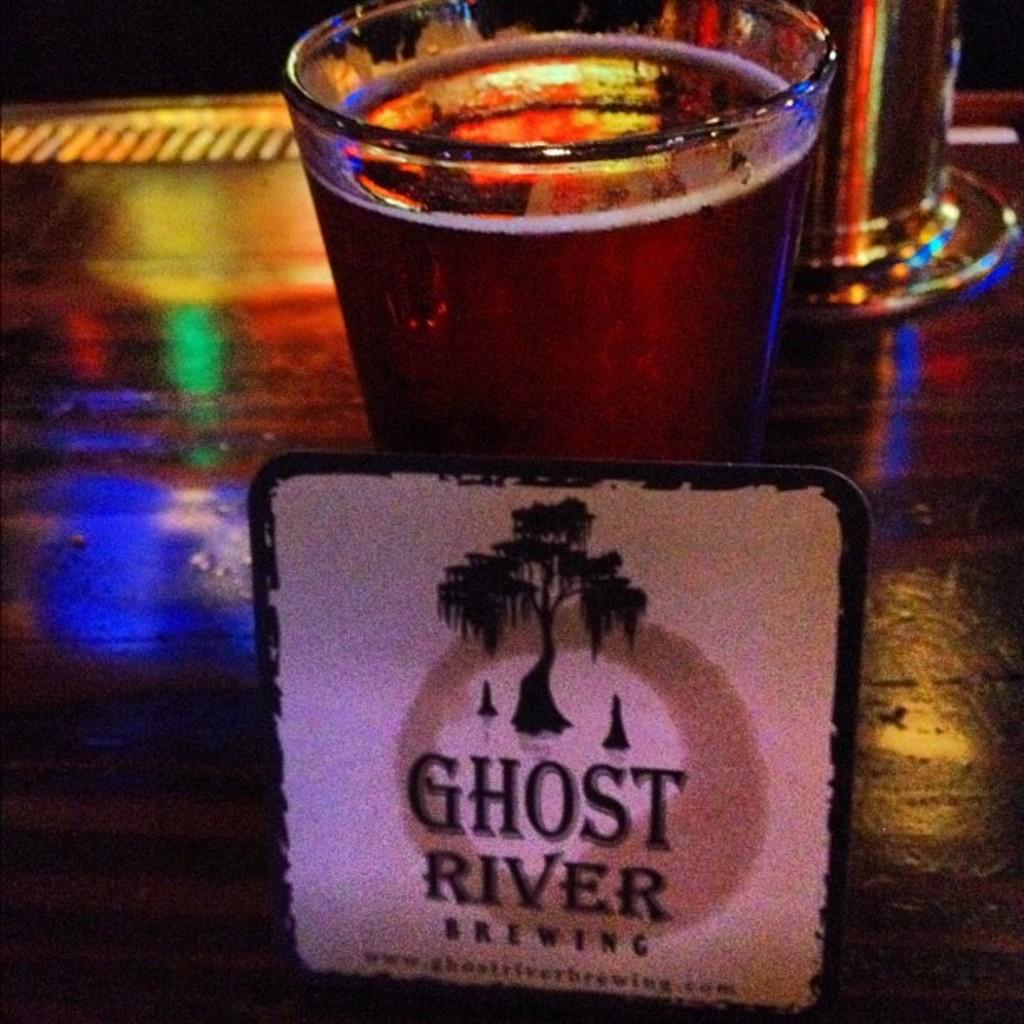Provide a one-sentence caption for the provided image. A coaster of Ghost River Brewing with a sweeping tree on the coaster. 